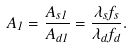<formula> <loc_0><loc_0><loc_500><loc_500>A _ { 1 } = \frac { A _ { s 1 } } { A _ { d 1 } } = \frac { \lambda _ { s } f _ { s } } { \lambda _ { d } f _ { d } } .</formula> 